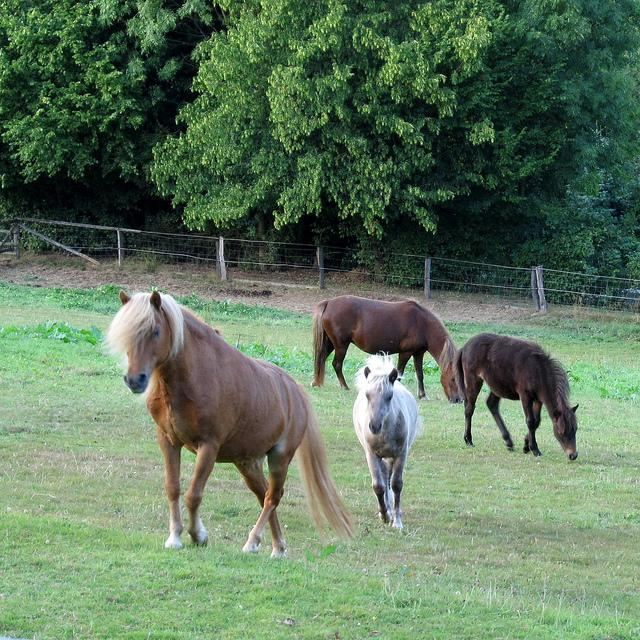What animals are present? horses 